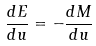<formula> <loc_0><loc_0><loc_500><loc_500>\frac { d E } { d u } = - \frac { d M } { d u }</formula> 